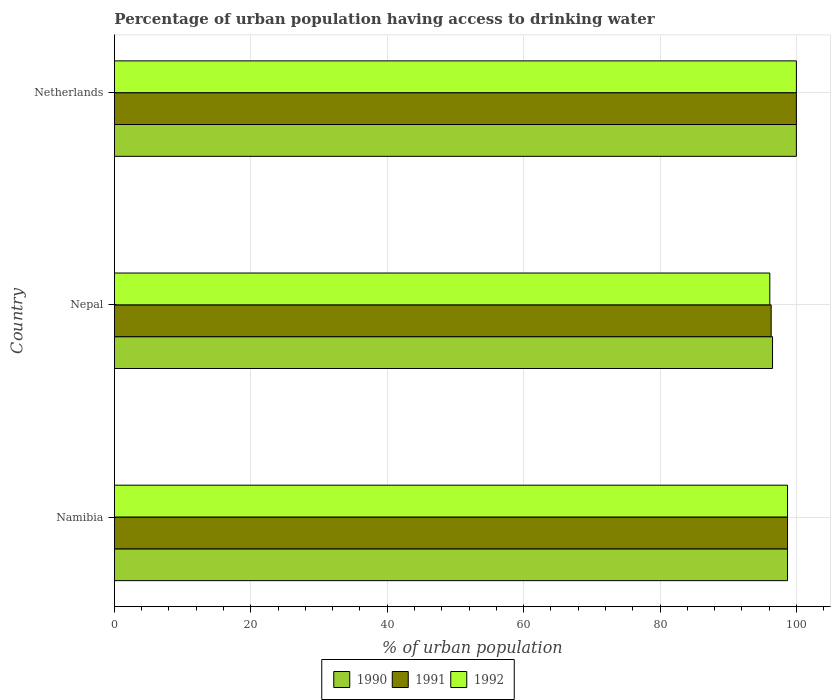How many different coloured bars are there?
Provide a short and direct response. 3. How many groups of bars are there?
Keep it short and to the point. 3. Are the number of bars on each tick of the Y-axis equal?
Your answer should be compact. Yes. How many bars are there on the 3rd tick from the top?
Make the answer very short. 3. How many bars are there on the 2nd tick from the bottom?
Your answer should be compact. 3. What is the label of the 3rd group of bars from the top?
Make the answer very short. Namibia. In how many cases, is the number of bars for a given country not equal to the number of legend labels?
Offer a very short reply. 0. What is the percentage of urban population having access to drinking water in 1991 in Nepal?
Keep it short and to the point. 96.3. Across all countries, what is the maximum percentage of urban population having access to drinking water in 1990?
Make the answer very short. 100. Across all countries, what is the minimum percentage of urban population having access to drinking water in 1992?
Offer a very short reply. 96.1. In which country was the percentage of urban population having access to drinking water in 1990 minimum?
Your response must be concise. Nepal. What is the total percentage of urban population having access to drinking water in 1991 in the graph?
Your answer should be compact. 295. What is the difference between the percentage of urban population having access to drinking water in 1991 in Namibia and that in Netherlands?
Your answer should be compact. -1.3. What is the difference between the percentage of urban population having access to drinking water in 1992 in Netherlands and the percentage of urban population having access to drinking water in 1990 in Nepal?
Offer a very short reply. 3.5. What is the average percentage of urban population having access to drinking water in 1991 per country?
Ensure brevity in your answer.  98.33. What is the difference between the percentage of urban population having access to drinking water in 1991 and percentage of urban population having access to drinking water in 1990 in Netherlands?
Your answer should be very brief. 0. In how many countries, is the percentage of urban population having access to drinking water in 1990 greater than 76 %?
Provide a short and direct response. 3. What is the ratio of the percentage of urban population having access to drinking water in 1992 in Namibia to that in Nepal?
Offer a very short reply. 1.03. Is the percentage of urban population having access to drinking water in 1991 in Nepal less than that in Netherlands?
Ensure brevity in your answer.  Yes. What is the difference between the highest and the second highest percentage of urban population having access to drinking water in 1992?
Your answer should be very brief. 1.3. What is the difference between the highest and the lowest percentage of urban population having access to drinking water in 1991?
Offer a terse response. 3.7. What does the 2nd bar from the top in Netherlands represents?
Your response must be concise. 1991. What does the 3rd bar from the bottom in Namibia represents?
Keep it short and to the point. 1992. How many bars are there?
Your answer should be very brief. 9. How many countries are there in the graph?
Your answer should be compact. 3. Where does the legend appear in the graph?
Keep it short and to the point. Bottom center. How many legend labels are there?
Provide a succinct answer. 3. How are the legend labels stacked?
Ensure brevity in your answer.  Horizontal. What is the title of the graph?
Ensure brevity in your answer.  Percentage of urban population having access to drinking water. What is the label or title of the X-axis?
Provide a succinct answer. % of urban population. What is the label or title of the Y-axis?
Provide a succinct answer. Country. What is the % of urban population of 1990 in Namibia?
Make the answer very short. 98.7. What is the % of urban population in 1991 in Namibia?
Give a very brief answer. 98.7. What is the % of urban population of 1992 in Namibia?
Keep it short and to the point. 98.7. What is the % of urban population of 1990 in Nepal?
Provide a short and direct response. 96.5. What is the % of urban population in 1991 in Nepal?
Provide a short and direct response. 96.3. What is the % of urban population in 1992 in Nepal?
Offer a terse response. 96.1. What is the % of urban population of 1991 in Netherlands?
Your response must be concise. 100. Across all countries, what is the maximum % of urban population of 1990?
Your response must be concise. 100. Across all countries, what is the maximum % of urban population of 1992?
Keep it short and to the point. 100. Across all countries, what is the minimum % of urban population in 1990?
Your response must be concise. 96.5. Across all countries, what is the minimum % of urban population of 1991?
Offer a terse response. 96.3. Across all countries, what is the minimum % of urban population in 1992?
Give a very brief answer. 96.1. What is the total % of urban population in 1990 in the graph?
Your response must be concise. 295.2. What is the total % of urban population in 1991 in the graph?
Your answer should be very brief. 295. What is the total % of urban population of 1992 in the graph?
Your response must be concise. 294.8. What is the difference between the % of urban population in 1992 in Namibia and that in Nepal?
Offer a terse response. 2.6. What is the difference between the % of urban population of 1990 in Namibia and that in Netherlands?
Your answer should be compact. -1.3. What is the difference between the % of urban population of 1991 in Namibia and that in Netherlands?
Offer a terse response. -1.3. What is the difference between the % of urban population in 1990 in Nepal and that in Netherlands?
Offer a very short reply. -3.5. What is the difference between the % of urban population of 1991 in Nepal and that in Netherlands?
Your answer should be compact. -3.7. What is the difference between the % of urban population in 1992 in Nepal and that in Netherlands?
Provide a succinct answer. -3.9. What is the difference between the % of urban population in 1990 in Namibia and the % of urban population in 1991 in Nepal?
Offer a very short reply. 2.4. What is the difference between the % of urban population in 1991 in Namibia and the % of urban population in 1992 in Nepal?
Provide a succinct answer. 2.6. What is the average % of urban population in 1990 per country?
Make the answer very short. 98.4. What is the average % of urban population of 1991 per country?
Ensure brevity in your answer.  98.33. What is the average % of urban population in 1992 per country?
Your response must be concise. 98.27. What is the difference between the % of urban population in 1990 and % of urban population in 1991 in Namibia?
Provide a succinct answer. 0. What is the difference between the % of urban population of 1990 and % of urban population of 1991 in Nepal?
Offer a very short reply. 0.2. What is the difference between the % of urban population in 1990 and % of urban population in 1992 in Nepal?
Offer a very short reply. 0.4. What is the difference between the % of urban population of 1990 and % of urban population of 1991 in Netherlands?
Your answer should be compact. 0. What is the difference between the % of urban population in 1990 and % of urban population in 1992 in Netherlands?
Your answer should be very brief. 0. What is the difference between the % of urban population of 1991 and % of urban population of 1992 in Netherlands?
Your response must be concise. 0. What is the ratio of the % of urban population of 1990 in Namibia to that in Nepal?
Ensure brevity in your answer.  1.02. What is the ratio of the % of urban population of 1991 in Namibia to that in Nepal?
Your answer should be very brief. 1.02. What is the ratio of the % of urban population of 1992 in Namibia to that in Nepal?
Your answer should be compact. 1.03. What is the ratio of the % of urban population in 1991 in Namibia to that in Netherlands?
Make the answer very short. 0.99. What is the ratio of the % of urban population in 1992 in Namibia to that in Netherlands?
Your response must be concise. 0.99. What is the ratio of the % of urban population in 1990 in Nepal to that in Netherlands?
Offer a terse response. 0.96. What is the difference between the highest and the second highest % of urban population of 1990?
Keep it short and to the point. 1.3. What is the difference between the highest and the second highest % of urban population of 1991?
Provide a succinct answer. 1.3. What is the difference between the highest and the second highest % of urban population of 1992?
Make the answer very short. 1.3. What is the difference between the highest and the lowest % of urban population of 1992?
Your answer should be very brief. 3.9. 